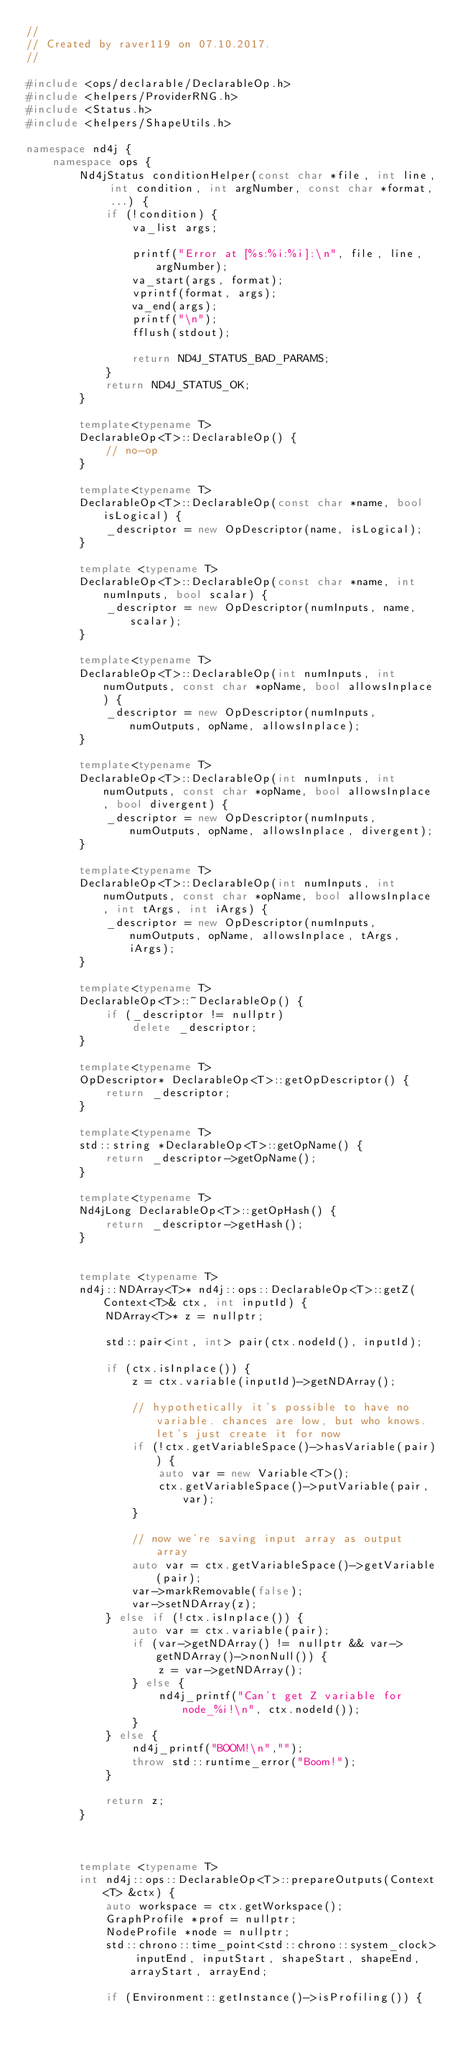Convert code to text. <code><loc_0><loc_0><loc_500><loc_500><_C++_>//
// Created by raver119 on 07.10.2017.
//

#include <ops/declarable/DeclarableOp.h>
#include <helpers/ProviderRNG.h>
#include <Status.h>
#include <helpers/ShapeUtils.h>

namespace nd4j {
    namespace ops {
        Nd4jStatus conditionHelper(const char *file, int line, int condition, int argNumber, const char *format, ...) {
            if (!condition) {
                va_list args;

                printf("Error at [%s:%i:%i]:\n", file, line, argNumber);
                va_start(args, format);
                vprintf(format, args);
                va_end(args);
                printf("\n");
                fflush(stdout);

                return ND4J_STATUS_BAD_PARAMS;
            }
            return ND4J_STATUS_OK;
        }

        template<typename T>
        DeclarableOp<T>::DeclarableOp() {
            // no-op
        }

        template<typename T>
        DeclarableOp<T>::DeclarableOp(const char *name, bool isLogical) {
            _descriptor = new OpDescriptor(name, isLogical);
        }

        template <typename T>
        DeclarableOp<T>::DeclarableOp(const char *name, int numInputs, bool scalar) {
            _descriptor = new OpDescriptor(numInputs, name, scalar);
        }

        template<typename T>
        DeclarableOp<T>::DeclarableOp(int numInputs, int numOutputs, const char *opName, bool allowsInplace) {
            _descriptor = new OpDescriptor(numInputs, numOutputs, opName, allowsInplace);
        }

        template<typename T>
        DeclarableOp<T>::DeclarableOp(int numInputs, int numOutputs, const char *opName, bool allowsInplace, bool divergent) {
            _descriptor = new OpDescriptor(numInputs, numOutputs, opName, allowsInplace, divergent);
        }

        template<typename T>
        DeclarableOp<T>::DeclarableOp(int numInputs, int numOutputs, const char *opName, bool allowsInplace, int tArgs, int iArgs) {
            _descriptor = new OpDescriptor(numInputs, numOutputs, opName, allowsInplace, tArgs, iArgs);
        }

        template<typename T>
        DeclarableOp<T>::~DeclarableOp() {
            if (_descriptor != nullptr)
                delete _descriptor;
        }

        template<typename T>
        OpDescriptor* DeclarableOp<T>::getOpDescriptor() {
            return _descriptor;
        }

        template<typename T>
        std::string *DeclarableOp<T>::getOpName() {
            return _descriptor->getOpName();
        }

        template<typename T>
        Nd4jLong DeclarableOp<T>::getOpHash() {
            return _descriptor->getHash();
        }


        template <typename T>
        nd4j::NDArray<T>* nd4j::ops::DeclarableOp<T>::getZ(Context<T>& ctx, int inputId) {
            NDArray<T>* z = nullptr;

            std::pair<int, int> pair(ctx.nodeId(), inputId);

            if (ctx.isInplace()) {
                z = ctx.variable(inputId)->getNDArray();

                // hypothetically it's possible to have no variable. chances are low, but who knows. let's just create it for now
                if (!ctx.getVariableSpace()->hasVariable(pair)) {
                    auto var = new Variable<T>();
                    ctx.getVariableSpace()->putVariable(pair, var);
                }

                // now we're saving input array as output array
                auto var = ctx.getVariableSpace()->getVariable(pair);
                var->markRemovable(false);
                var->setNDArray(z);
            } else if (!ctx.isInplace()) {
                auto var = ctx.variable(pair);
                if (var->getNDArray() != nullptr && var->getNDArray()->nonNull()) {
                    z = var->getNDArray();
                } else {
                    nd4j_printf("Can't get Z variable for node_%i!\n", ctx.nodeId());
                }
            } else {
                nd4j_printf("BOOM!\n","");
                throw std::runtime_error("Boom!");
            }

            return z;
        }



        template <typename T>
        int nd4j::ops::DeclarableOp<T>::prepareOutputs(Context<T> &ctx) {
            auto workspace = ctx.getWorkspace();
            GraphProfile *prof = nullptr;
            NodeProfile *node = nullptr;
            std::chrono::time_point<std::chrono::system_clock> inputEnd, inputStart, shapeStart, shapeEnd, arrayStart, arrayEnd;

            if (Environment::getInstance()->isProfiling()) {</code> 